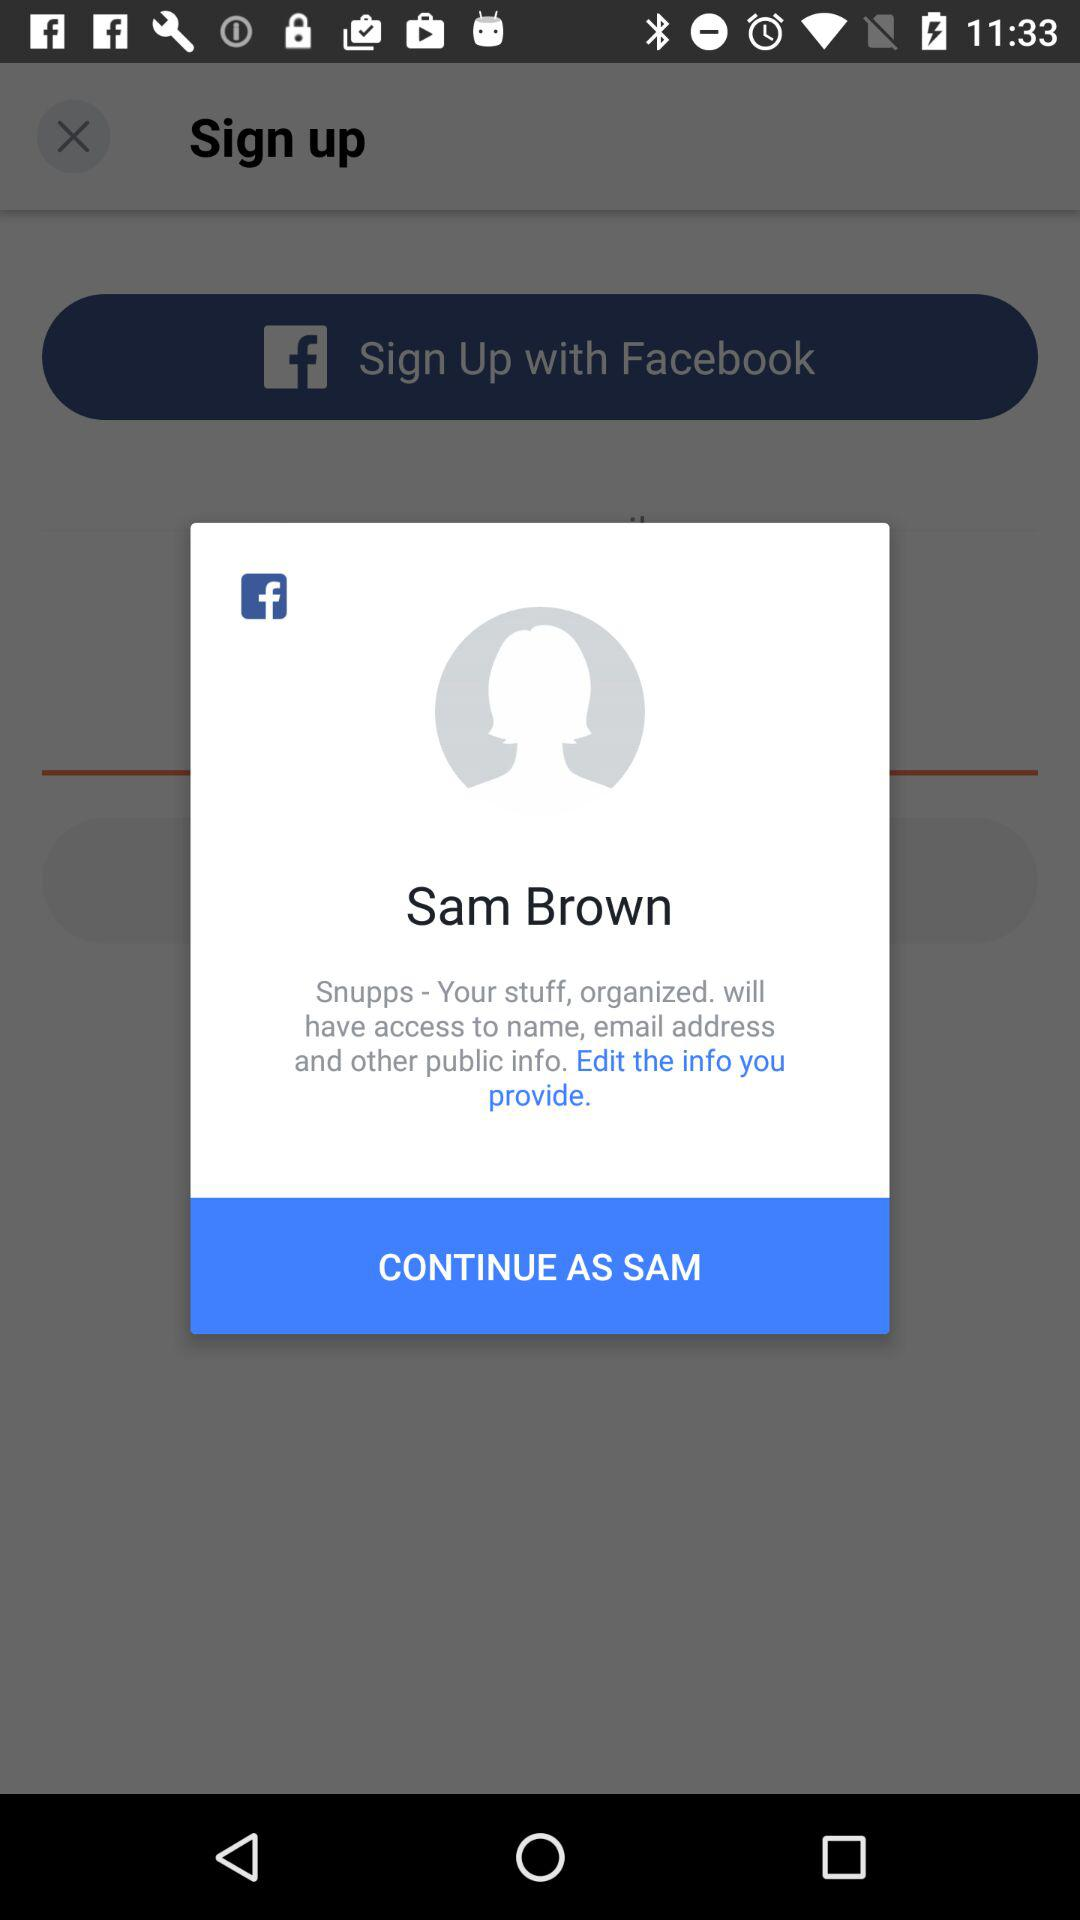How tall is Sam Brown?
When the provided information is insufficient, respond with <no answer>. <no answer> 